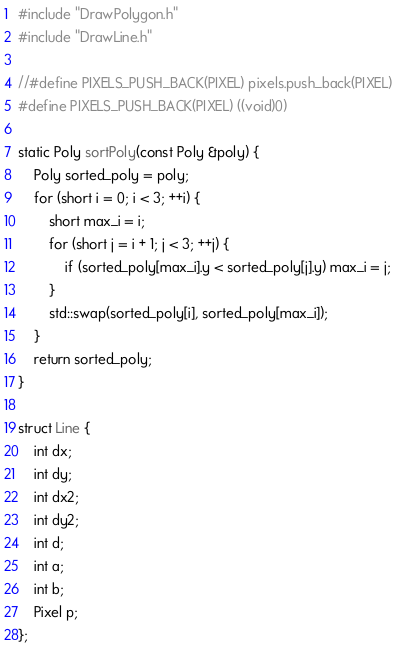<code> <loc_0><loc_0><loc_500><loc_500><_C++_>#include "DrawPolygon.h"
#include "DrawLine.h"

//#define PIXELS_PUSH_BACK(PIXEL) pixels.push_back(PIXEL)
#define PIXELS_PUSH_BACK(PIXEL) ((void)0)

static Poly sortPoly(const Poly &poly) {
	Poly sorted_poly = poly;
	for (short i = 0; i < 3; ++i) {
		short max_i = i;
		for (short j = i + 1; j < 3; ++j) {
			if (sorted_poly[max_i].y < sorted_poly[j].y) max_i = j;
		}
		std::swap(sorted_poly[i], sorted_poly[max_i]);
	}
	return sorted_poly;
}

struct Line {
	int dx;
	int dy;
	int dx2;
	int dy2;
	int d;
	int a;
	int b;
	Pixel p;
};
</code> 